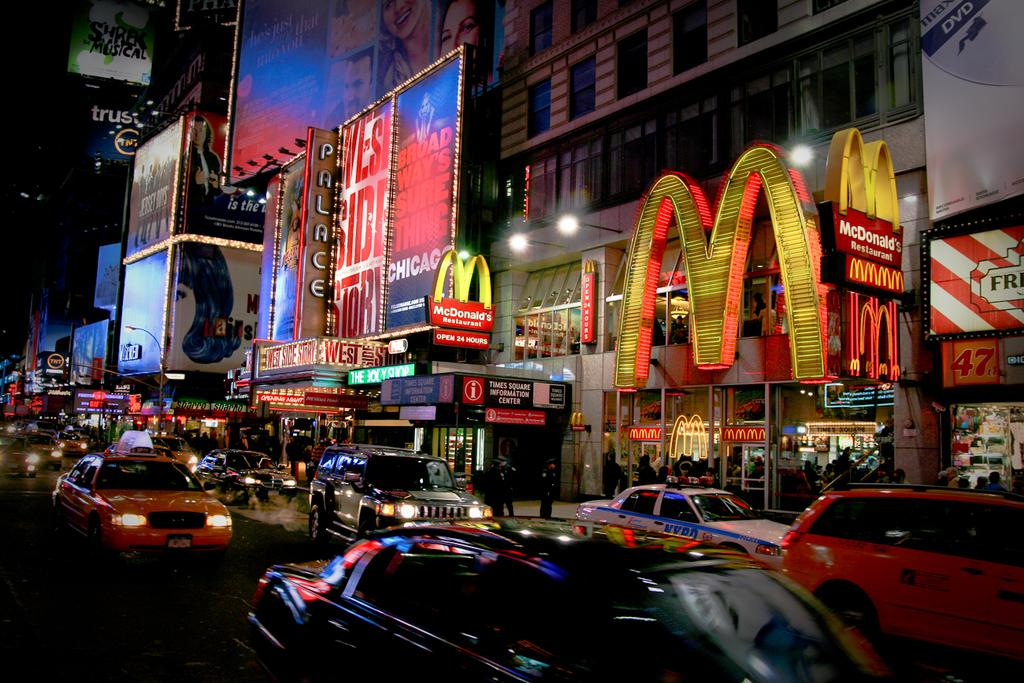<image>
Give a short and clear explanation of the subsequent image. traffic on the street in front of mcdonalds and the west side story thetere 